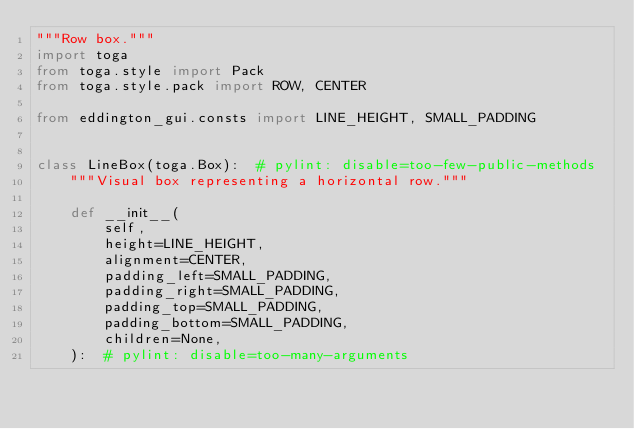Convert code to text. <code><loc_0><loc_0><loc_500><loc_500><_Python_>"""Row box."""
import toga
from toga.style import Pack
from toga.style.pack import ROW, CENTER

from eddington_gui.consts import LINE_HEIGHT, SMALL_PADDING


class LineBox(toga.Box):  # pylint: disable=too-few-public-methods
    """Visual box representing a horizontal row."""

    def __init__(
        self,
        height=LINE_HEIGHT,
        alignment=CENTER,
        padding_left=SMALL_PADDING,
        padding_right=SMALL_PADDING,
        padding_top=SMALL_PADDING,
        padding_bottom=SMALL_PADDING,
        children=None,
    ):  # pylint: disable=too-many-arguments</code> 